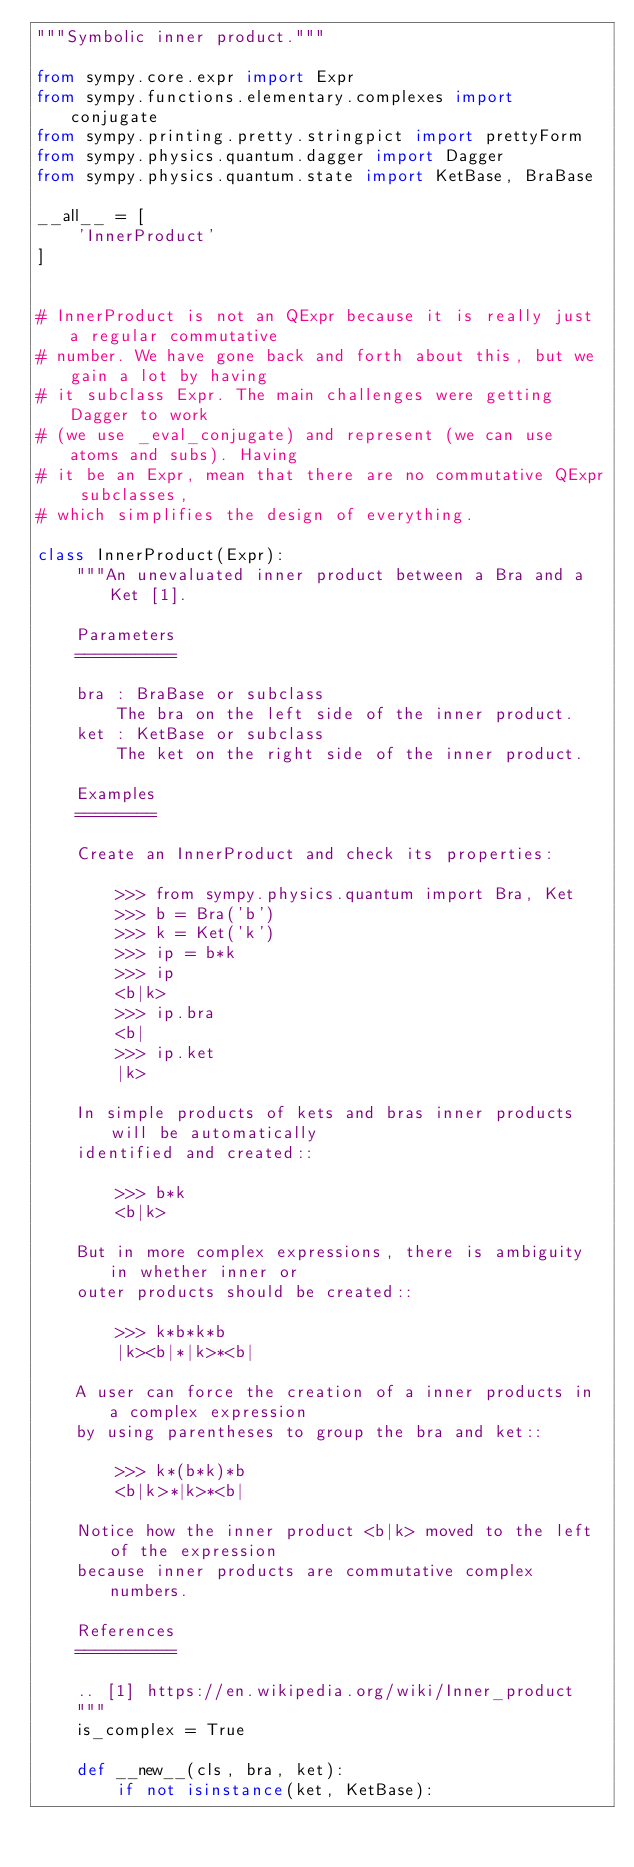Convert code to text. <code><loc_0><loc_0><loc_500><loc_500><_Python_>"""Symbolic inner product."""

from sympy.core.expr import Expr
from sympy.functions.elementary.complexes import conjugate
from sympy.printing.pretty.stringpict import prettyForm
from sympy.physics.quantum.dagger import Dagger
from sympy.physics.quantum.state import KetBase, BraBase

__all__ = [
    'InnerProduct'
]


# InnerProduct is not an QExpr because it is really just a regular commutative
# number. We have gone back and forth about this, but we gain a lot by having
# it subclass Expr. The main challenges were getting Dagger to work
# (we use _eval_conjugate) and represent (we can use atoms and subs). Having
# it be an Expr, mean that there are no commutative QExpr subclasses,
# which simplifies the design of everything.

class InnerProduct(Expr):
    """An unevaluated inner product between a Bra and a Ket [1].

    Parameters
    ==========

    bra : BraBase or subclass
        The bra on the left side of the inner product.
    ket : KetBase or subclass
        The ket on the right side of the inner product.

    Examples
    ========

    Create an InnerProduct and check its properties:

        >>> from sympy.physics.quantum import Bra, Ket
        >>> b = Bra('b')
        >>> k = Ket('k')
        >>> ip = b*k
        >>> ip
        <b|k>
        >>> ip.bra
        <b|
        >>> ip.ket
        |k>

    In simple products of kets and bras inner products will be automatically
    identified and created::

        >>> b*k
        <b|k>

    But in more complex expressions, there is ambiguity in whether inner or
    outer products should be created::

        >>> k*b*k*b
        |k><b|*|k>*<b|

    A user can force the creation of a inner products in a complex expression
    by using parentheses to group the bra and ket::

        >>> k*(b*k)*b
        <b|k>*|k>*<b|

    Notice how the inner product <b|k> moved to the left of the expression
    because inner products are commutative complex numbers.

    References
    ==========

    .. [1] https://en.wikipedia.org/wiki/Inner_product
    """
    is_complex = True

    def __new__(cls, bra, ket):
        if not isinstance(ket, KetBase):</code> 